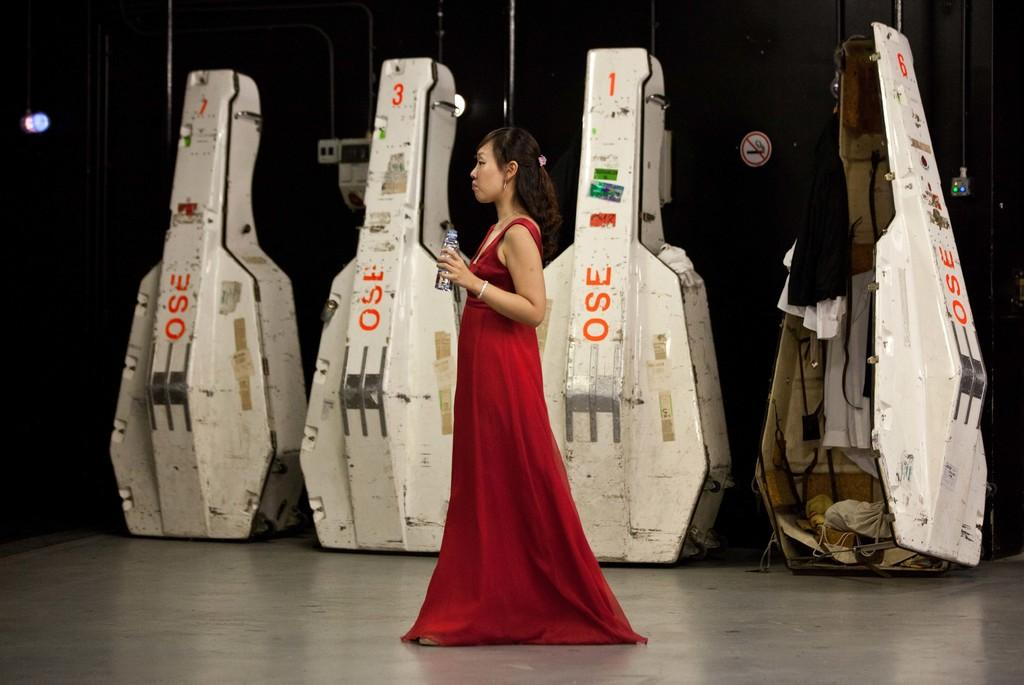What objects are placed on the dais in the image? There are boxes on a dais in the image. Who is present in the image? There is a woman standing in the image. What is the woman holding in her hand? The woman is holding a bottle in her hand. What type of sign can be seen in the image? There is a caution board in the image. What type of spoon is being used in the process depicted in the image? There is no spoon or any process being depicted in the image; it features boxes on a dais, a woman holding a bottle, and a caution board. 